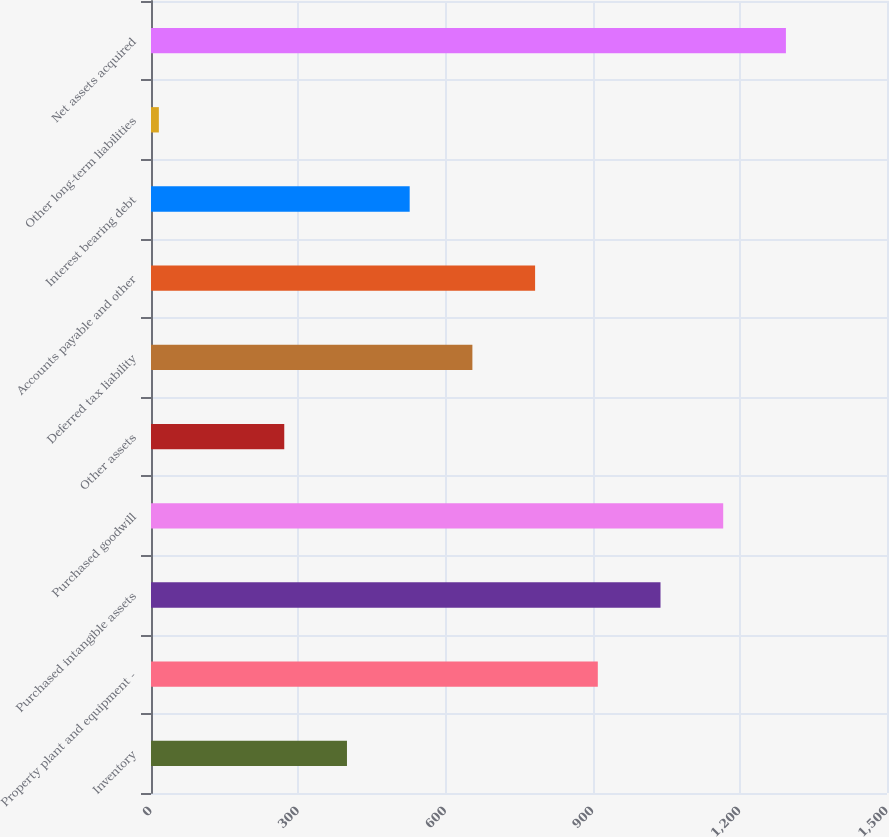Convert chart. <chart><loc_0><loc_0><loc_500><loc_500><bar_chart><fcel>Inventory<fcel>Property plant and equipment -<fcel>Purchased intangible assets<fcel>Purchased goodwill<fcel>Other assets<fcel>Deferred tax liability<fcel>Accounts payable and other<fcel>Interest bearing debt<fcel>Other long-term liabilities<fcel>Net assets acquired<nl><fcel>399.4<fcel>910.6<fcel>1038.4<fcel>1166.2<fcel>271.6<fcel>655<fcel>782.8<fcel>527.2<fcel>16<fcel>1294<nl></chart> 